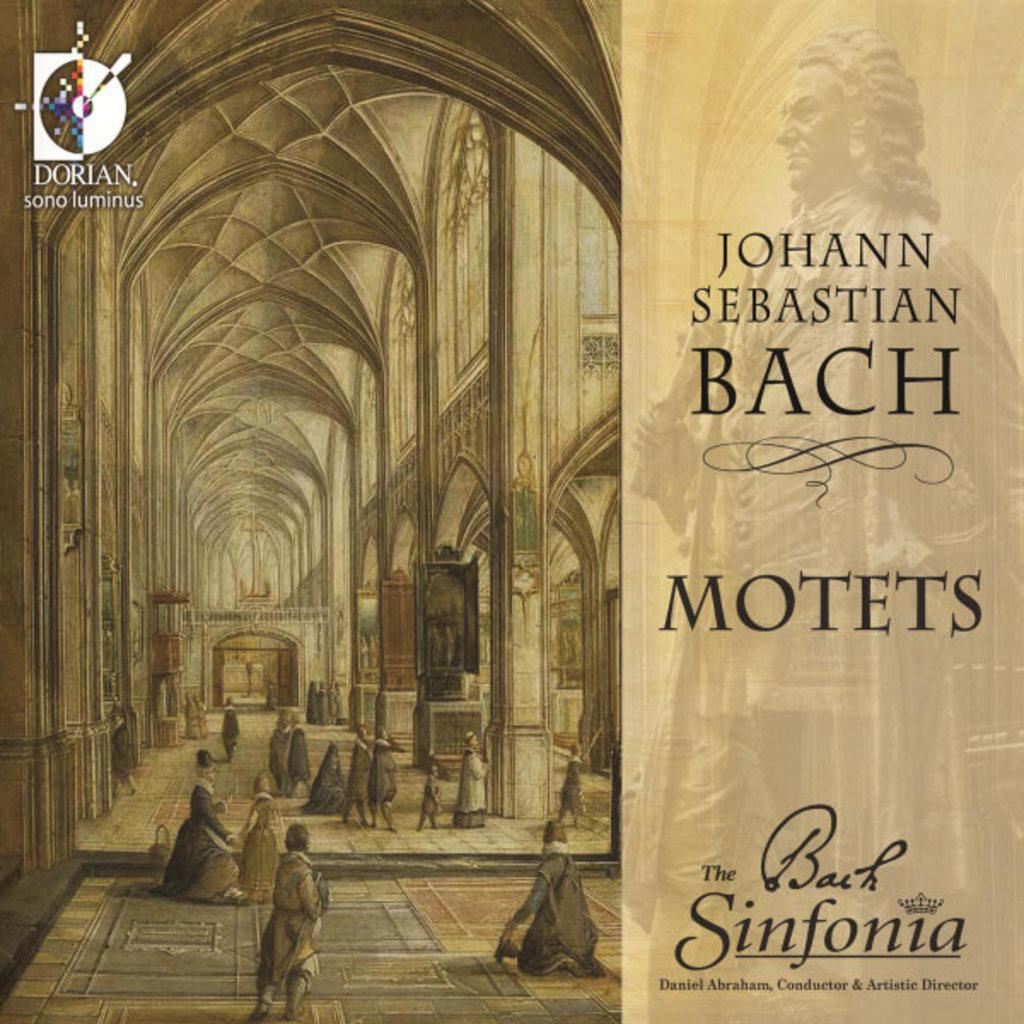<image>
Give a short and clear explanation of the subsequent image. Motets by Johann Sebastian Bach is in a case. 